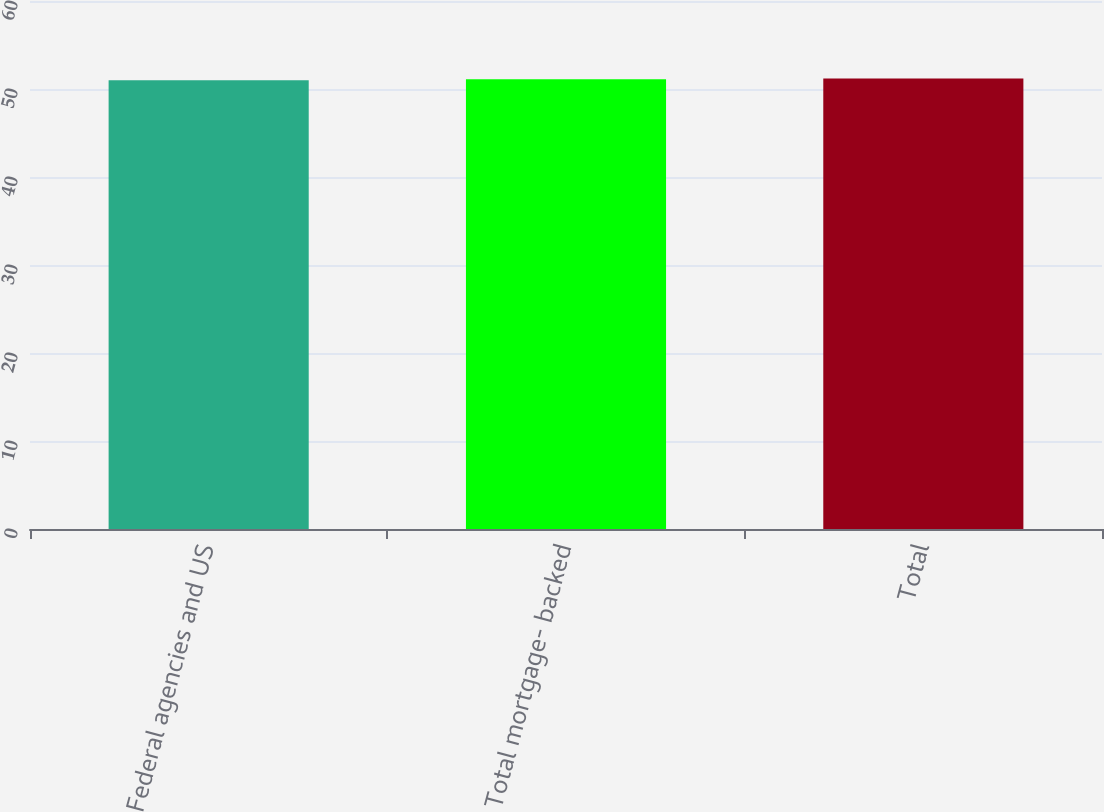<chart> <loc_0><loc_0><loc_500><loc_500><bar_chart><fcel>Federal agencies and US<fcel>Total mortgage- backed<fcel>Total<nl><fcel>51<fcel>51.1<fcel>51.2<nl></chart> 